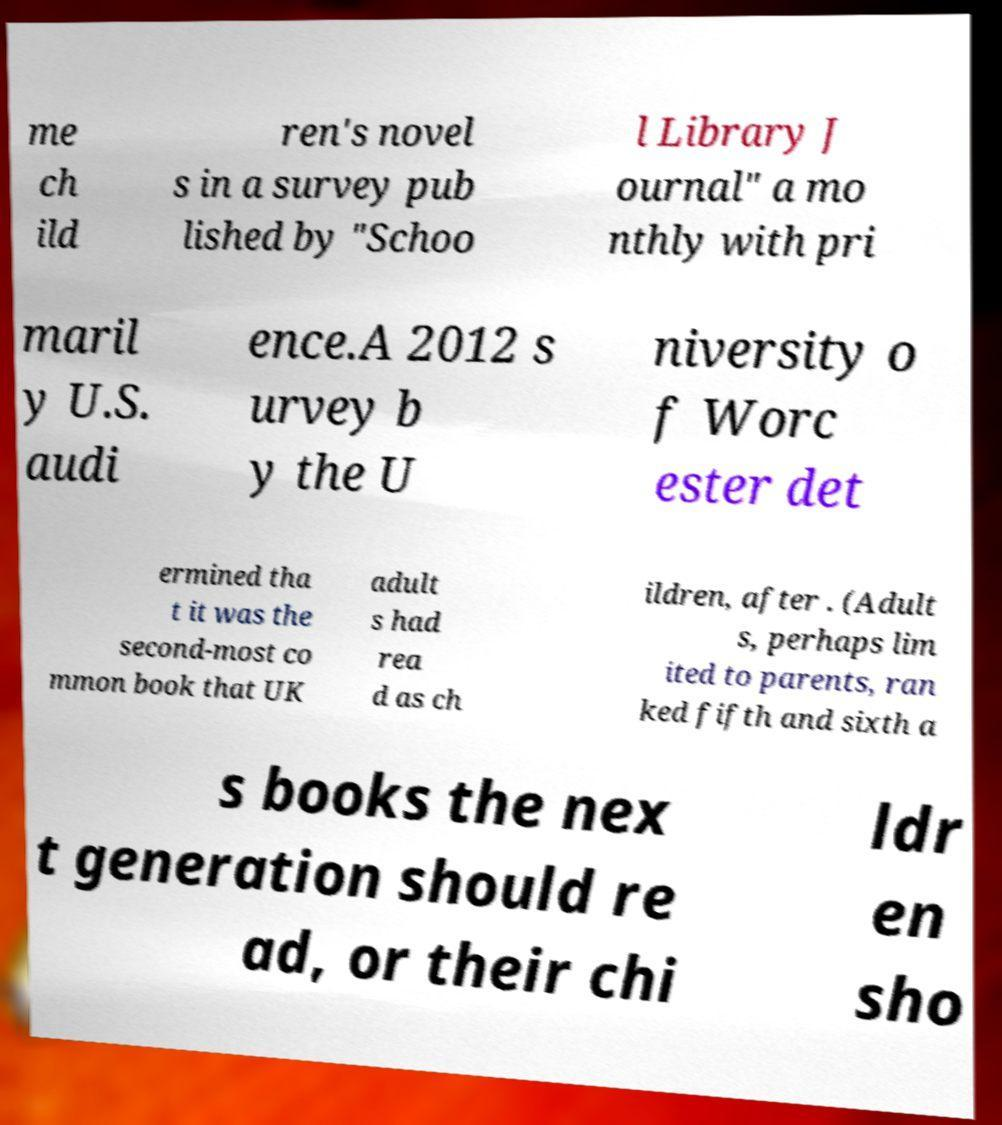I need the written content from this picture converted into text. Can you do that? me ch ild ren's novel s in a survey pub lished by "Schoo l Library J ournal" a mo nthly with pri maril y U.S. audi ence.A 2012 s urvey b y the U niversity o f Worc ester det ermined tha t it was the second-most co mmon book that UK adult s had rea d as ch ildren, after . (Adult s, perhaps lim ited to parents, ran ked fifth and sixth a s books the nex t generation should re ad, or their chi ldr en sho 